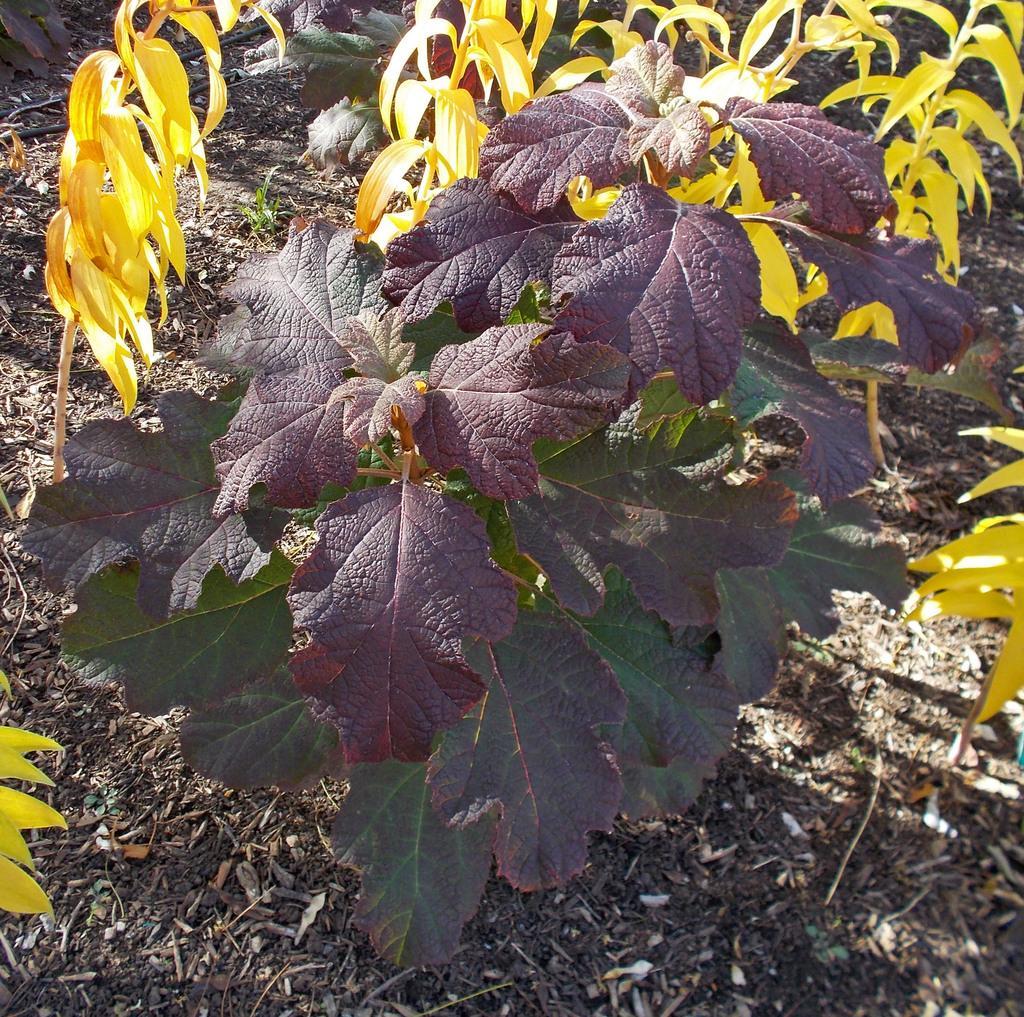Could you give a brief overview of what you see in this image? In the middle of this image, there is a plant having leaves on the ground. On the left side, there are plants having yellow color leaves. On the right side, there is a plant having yellow color leaves. In the background, there are plants having yellow color leaves. 